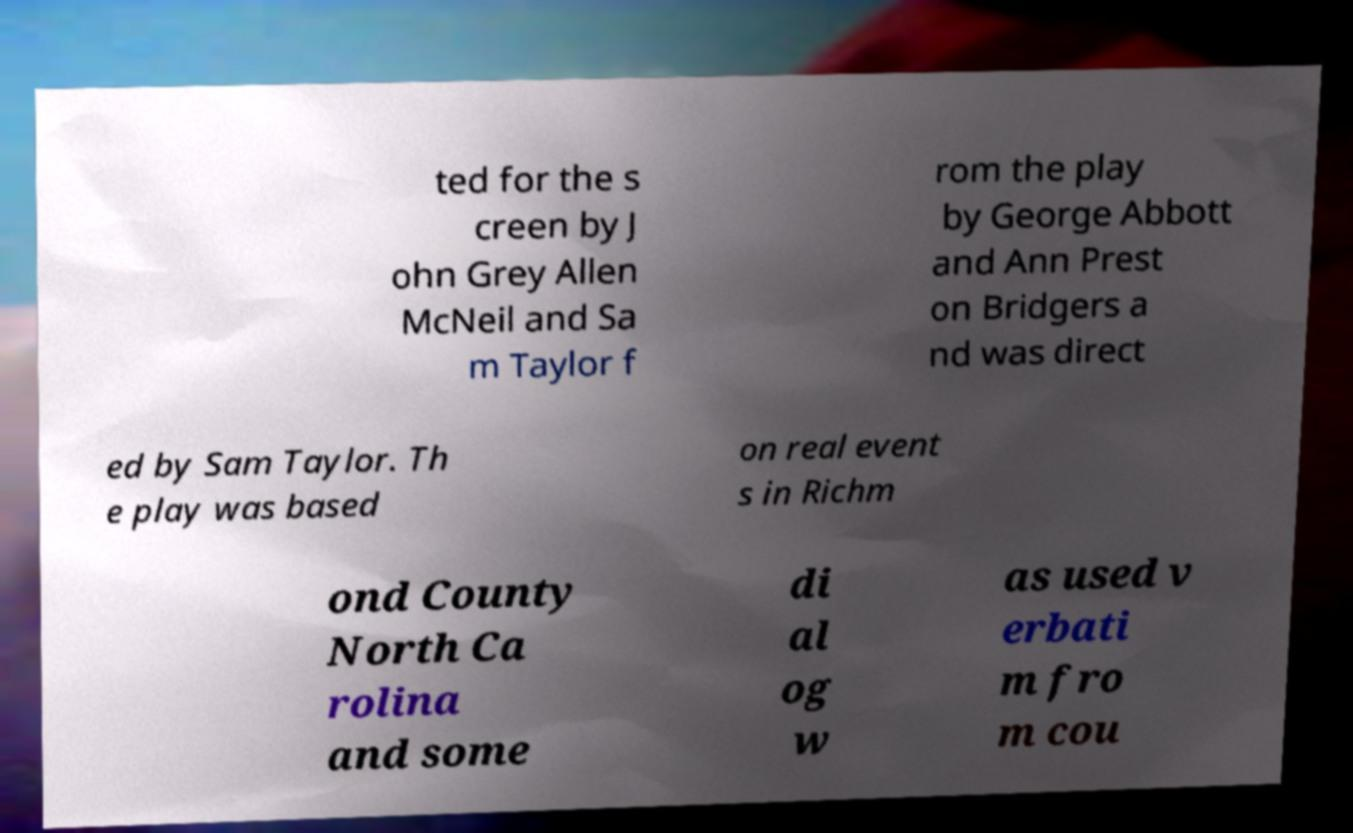There's text embedded in this image that I need extracted. Can you transcribe it verbatim? ted for the s creen by J ohn Grey Allen McNeil and Sa m Taylor f rom the play by George Abbott and Ann Prest on Bridgers a nd was direct ed by Sam Taylor. Th e play was based on real event s in Richm ond County North Ca rolina and some di al og w as used v erbati m fro m cou 